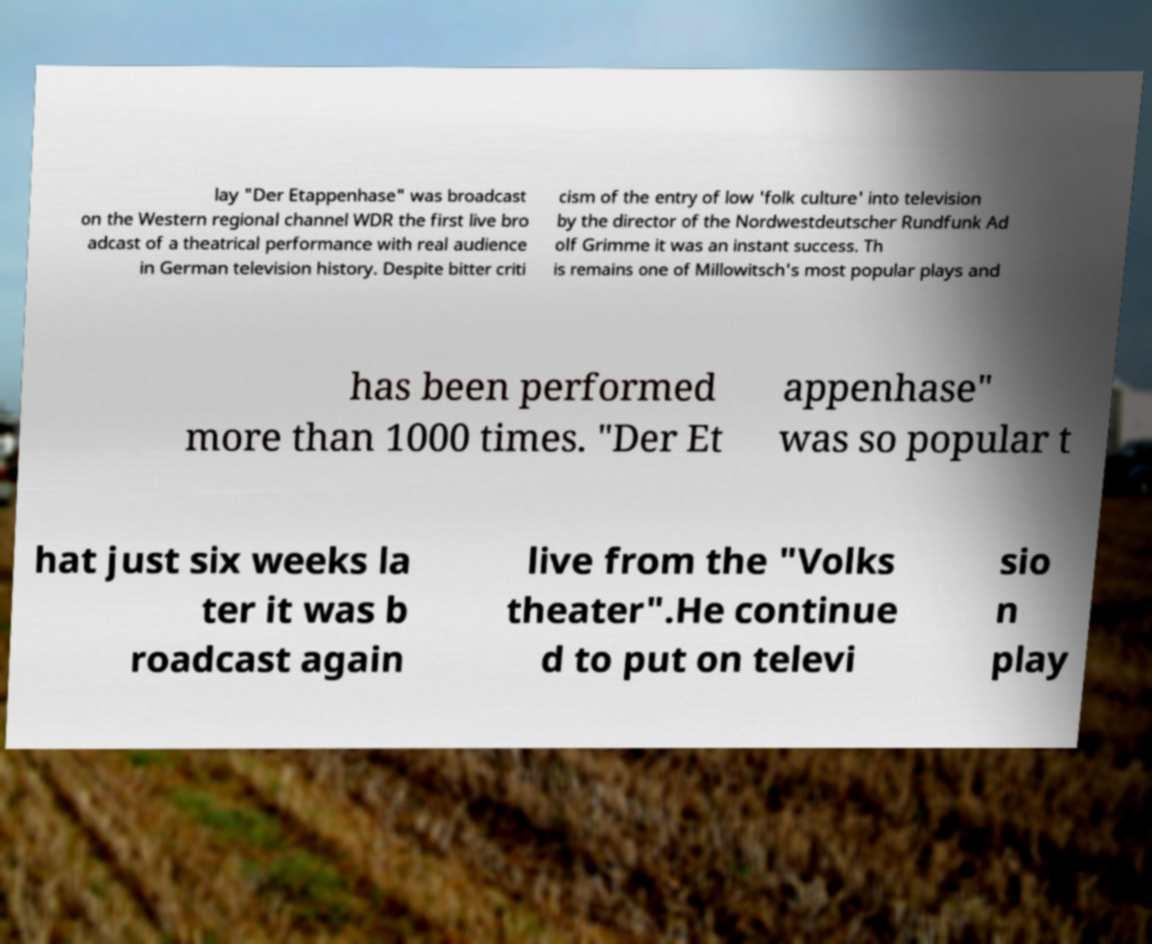For documentation purposes, I need the text within this image transcribed. Could you provide that? lay "Der Etappenhase" was broadcast on the Western regional channel WDR the first live bro adcast of a theatrical performance with real audience in German television history. Despite bitter criti cism of the entry of low 'folk culture' into television by the director of the Nordwestdeutscher Rundfunk Ad olf Grimme it was an instant success. Th is remains one of Millowitsch's most popular plays and has been performed more than 1000 times. "Der Et appenhase" was so popular t hat just six weeks la ter it was b roadcast again live from the "Volks theater".He continue d to put on televi sio n play 